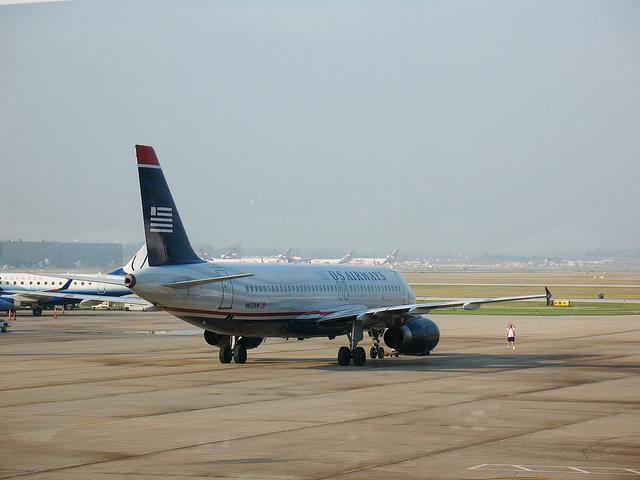How many airplanes are there?
Give a very brief answer. 2. How many dogs on a leash are in the picture?
Give a very brief answer. 0. 